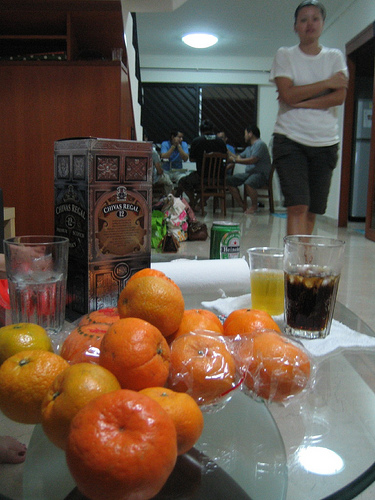What's the occasion here? It's difficult to specify the exact occasion without more context, but it seems like a casual gathering. There is a box of Costa Rican coffee on the table, and typically, such gatherings might include enjoying beverages and snacks while socializing. 